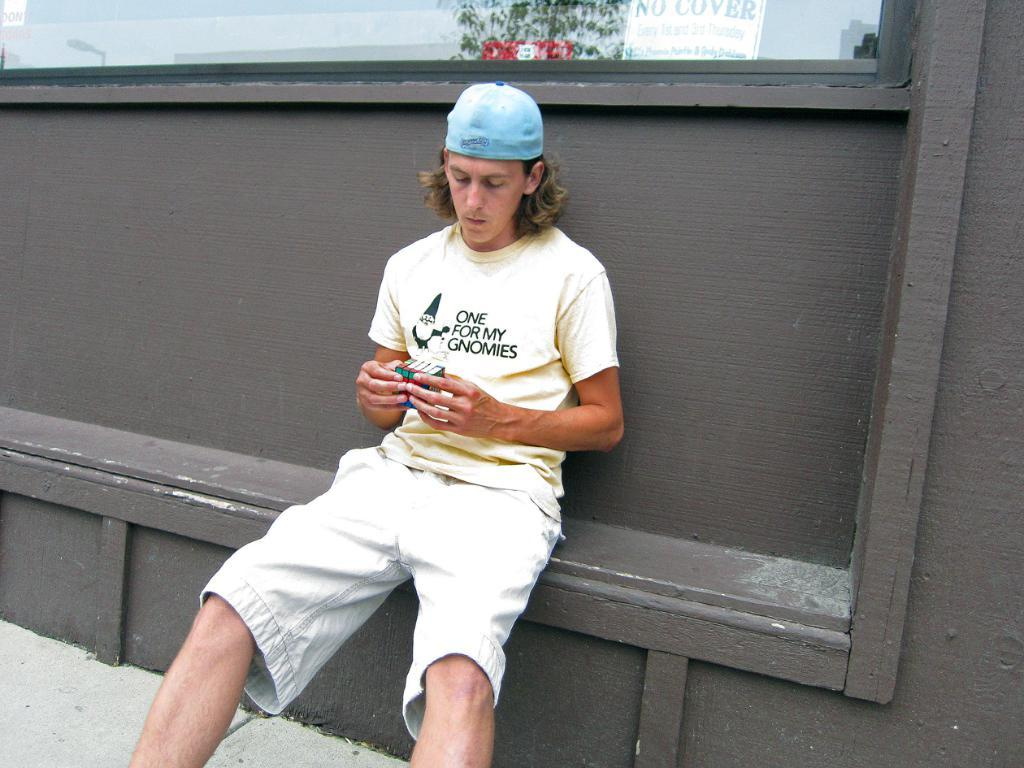What is the person in the image doing? There is a person sitting in the image. What object is the person holding? The person is holding a cube. What can be seen behind the person? There is a wooden wall behind the person. What type of container is visible in the image? There is a glass in the image. What type of written material is present in the image? There is a paper with text in the image. What type of money is being waved in the image? There is no money visible in the image; the person is holding a cube. What type of flag is present in the image? There is no flag present in the image. 